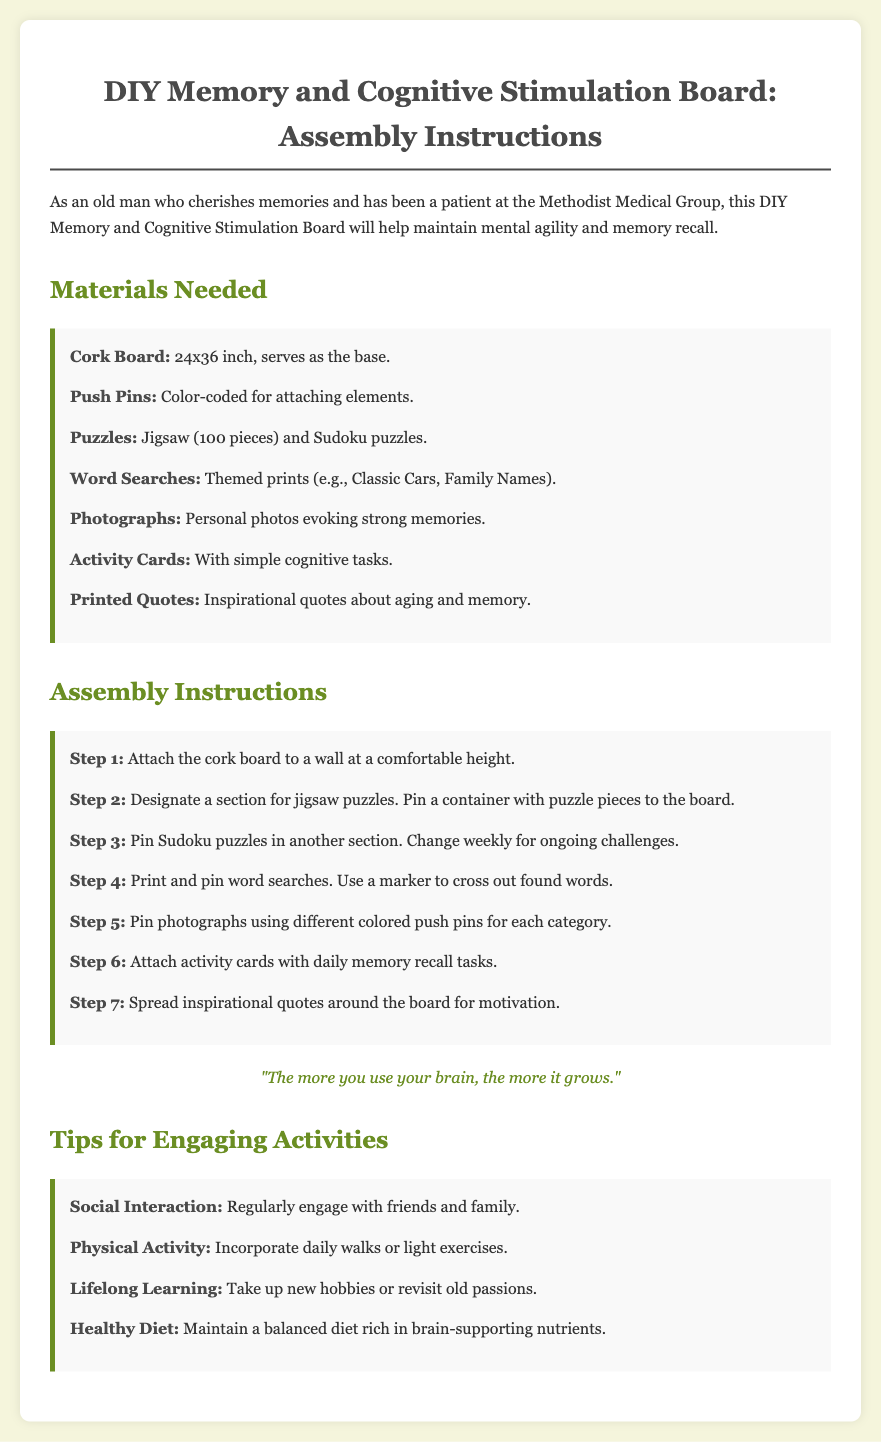What is the size of the cork board? The cork board size is provided under materials needed. It states 24x36 inch.
Answer: 24x36 inch How many types of puzzles are mentioned? The materials section lists the types of puzzles included—jigsaw and Sudoku. Therefore, there are 2 types.
Answer: 2 What is the purpose of the activity cards? The assembly instructions mention that activity cards contain daily memory recall tasks for cognitive engagement.
Answer: Daily memory recall tasks In which step do you pin photographs? The assembly instructions indicate that photographs should be pinned in Step 5.
Answer: Step 5 What color are the push pins specified to be? The materials state that the push pins should be color-coded for attaching elements.
Answer: Color-coded What is one recommendation for engaging activities? The tips section suggests various activities; one specific recommendation is to regularly engage with friends and family.
Answer: Social Interaction What kind of quotes are included on the board? The materials list that printed quotes should be inspirational and relate to aging and memory.
Answer: Inspirational quotes How often should Sudoku puzzles be changed? The assembly instructions state that Sudoku puzzles should be changed weekly for ongoing challenges.
Answer: Weekly 